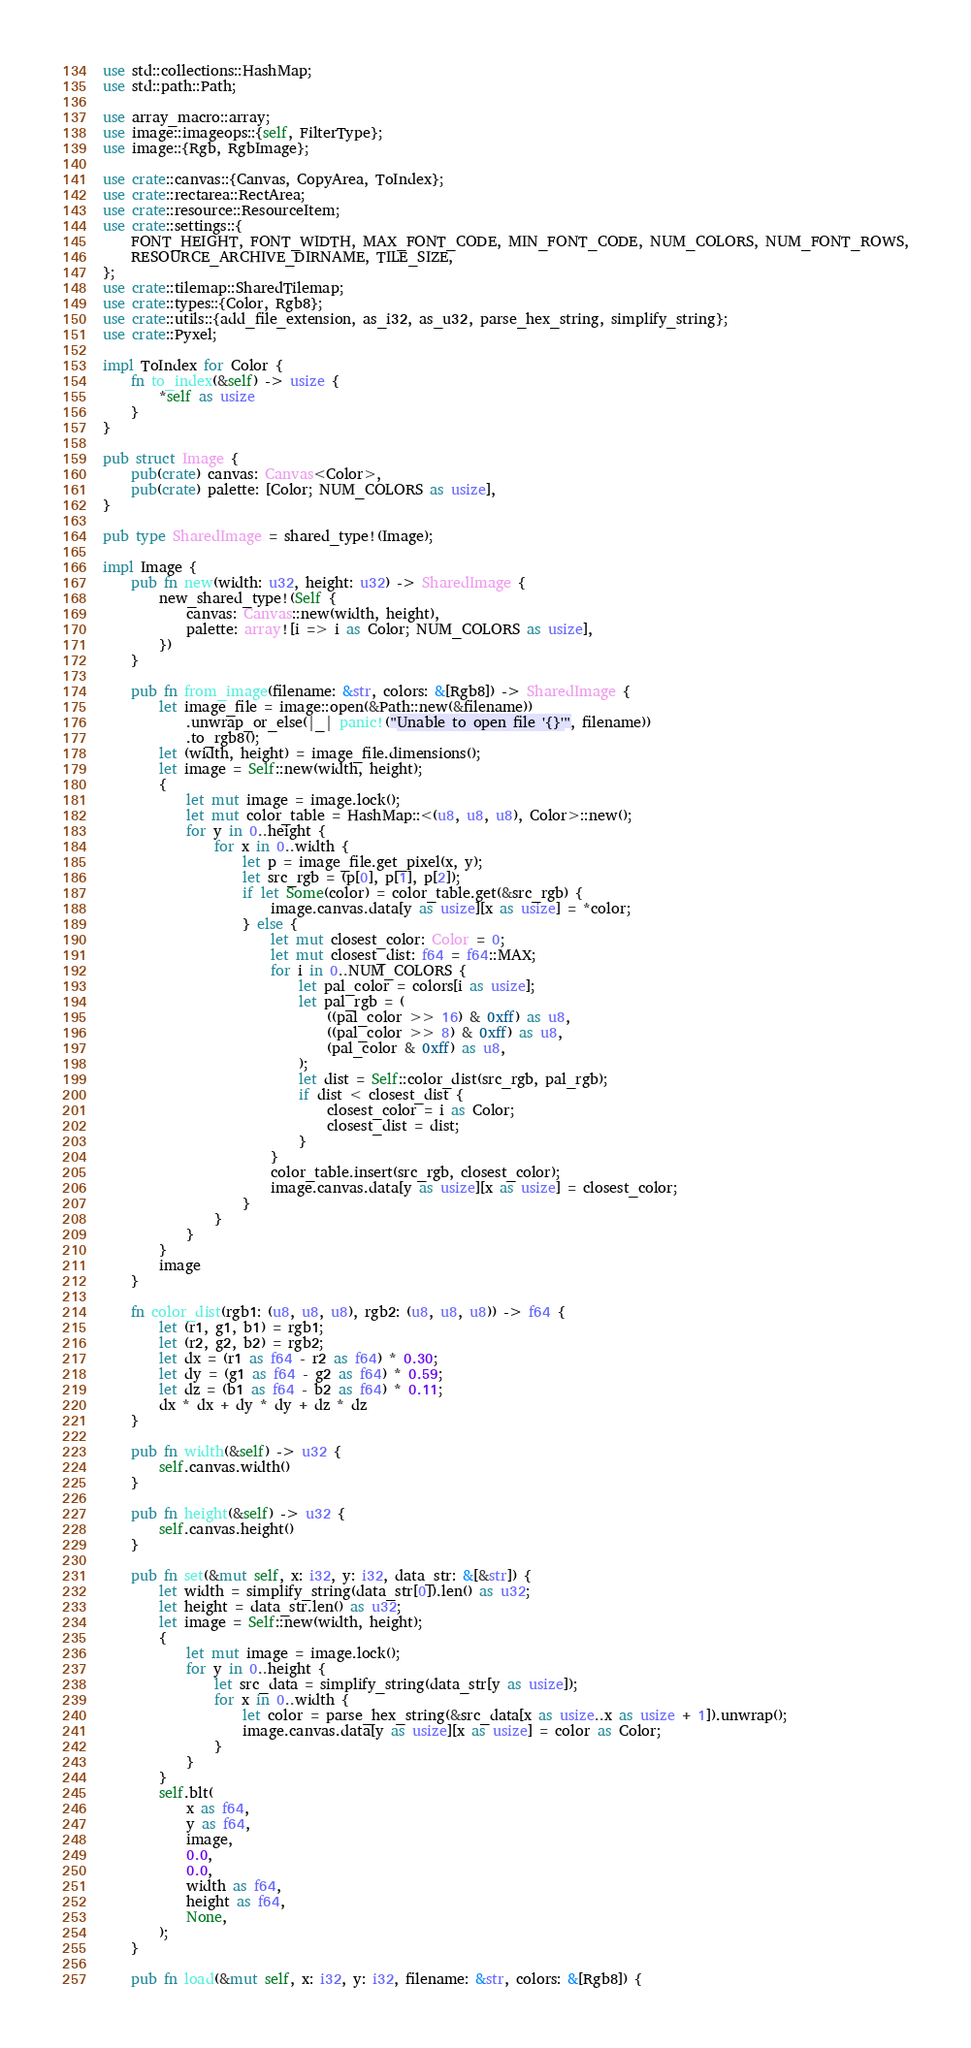<code> <loc_0><loc_0><loc_500><loc_500><_Rust_>use std::collections::HashMap;
use std::path::Path;

use array_macro::array;
use image::imageops::{self, FilterType};
use image::{Rgb, RgbImage};

use crate::canvas::{Canvas, CopyArea, ToIndex};
use crate::rectarea::RectArea;
use crate::resource::ResourceItem;
use crate::settings::{
    FONT_HEIGHT, FONT_WIDTH, MAX_FONT_CODE, MIN_FONT_CODE, NUM_COLORS, NUM_FONT_ROWS,
    RESOURCE_ARCHIVE_DIRNAME, TILE_SIZE,
};
use crate::tilemap::SharedTilemap;
use crate::types::{Color, Rgb8};
use crate::utils::{add_file_extension, as_i32, as_u32, parse_hex_string, simplify_string};
use crate::Pyxel;

impl ToIndex for Color {
    fn to_index(&self) -> usize {
        *self as usize
    }
}

pub struct Image {
    pub(crate) canvas: Canvas<Color>,
    pub(crate) palette: [Color; NUM_COLORS as usize],
}

pub type SharedImage = shared_type!(Image);

impl Image {
    pub fn new(width: u32, height: u32) -> SharedImage {
        new_shared_type!(Self {
            canvas: Canvas::new(width, height),
            palette: array![i => i as Color; NUM_COLORS as usize],
        })
    }

    pub fn from_image(filename: &str, colors: &[Rgb8]) -> SharedImage {
        let image_file = image::open(&Path::new(&filename))
            .unwrap_or_else(|_| panic!("Unable to open file '{}'", filename))
            .to_rgb8();
        let (width, height) = image_file.dimensions();
        let image = Self::new(width, height);
        {
            let mut image = image.lock();
            let mut color_table = HashMap::<(u8, u8, u8), Color>::new();
            for y in 0..height {
                for x in 0..width {
                    let p = image_file.get_pixel(x, y);
                    let src_rgb = (p[0], p[1], p[2]);
                    if let Some(color) = color_table.get(&src_rgb) {
                        image.canvas.data[y as usize][x as usize] = *color;
                    } else {
                        let mut closest_color: Color = 0;
                        let mut closest_dist: f64 = f64::MAX;
                        for i in 0..NUM_COLORS {
                            let pal_color = colors[i as usize];
                            let pal_rgb = (
                                ((pal_color >> 16) & 0xff) as u8,
                                ((pal_color >> 8) & 0xff) as u8,
                                (pal_color & 0xff) as u8,
                            );
                            let dist = Self::color_dist(src_rgb, pal_rgb);
                            if dist < closest_dist {
                                closest_color = i as Color;
                                closest_dist = dist;
                            }
                        }
                        color_table.insert(src_rgb, closest_color);
                        image.canvas.data[y as usize][x as usize] = closest_color;
                    }
                }
            }
        }
        image
    }

    fn color_dist(rgb1: (u8, u8, u8), rgb2: (u8, u8, u8)) -> f64 {
        let (r1, g1, b1) = rgb1;
        let (r2, g2, b2) = rgb2;
        let dx = (r1 as f64 - r2 as f64) * 0.30;
        let dy = (g1 as f64 - g2 as f64) * 0.59;
        let dz = (b1 as f64 - b2 as f64) * 0.11;
        dx * dx + dy * dy + dz * dz
    }

    pub fn width(&self) -> u32 {
        self.canvas.width()
    }

    pub fn height(&self) -> u32 {
        self.canvas.height()
    }

    pub fn set(&mut self, x: i32, y: i32, data_str: &[&str]) {
        let width = simplify_string(data_str[0]).len() as u32;
        let height = data_str.len() as u32;
        let image = Self::new(width, height);
        {
            let mut image = image.lock();
            for y in 0..height {
                let src_data = simplify_string(data_str[y as usize]);
                for x in 0..width {
                    let color = parse_hex_string(&src_data[x as usize..x as usize + 1]).unwrap();
                    image.canvas.data[y as usize][x as usize] = color as Color;
                }
            }
        }
        self.blt(
            x as f64,
            y as f64,
            image,
            0.0,
            0.0,
            width as f64,
            height as f64,
            None,
        );
    }

    pub fn load(&mut self, x: i32, y: i32, filename: &str, colors: &[Rgb8]) {</code> 